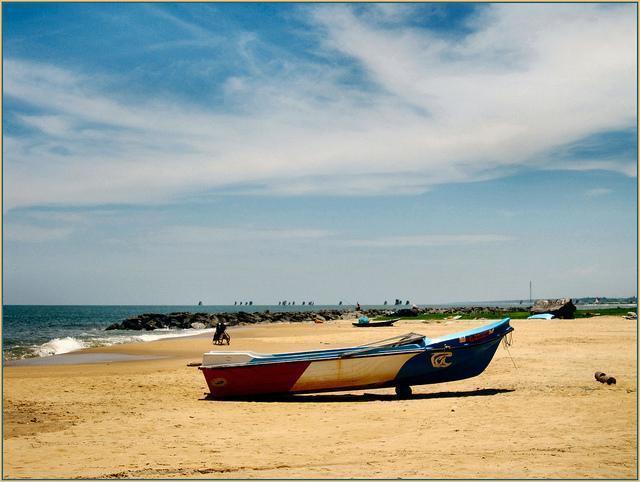Who might use the boat on the beach?
Select the accurate answer and provide justification: `Answer: choice
Rationale: srationale.`
Options: Lifeguards, senators, custodians, police. Answer: lifeguards.
Rationale: The boat is for emergency use. 